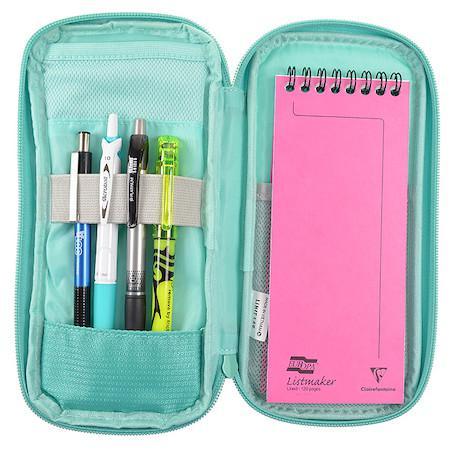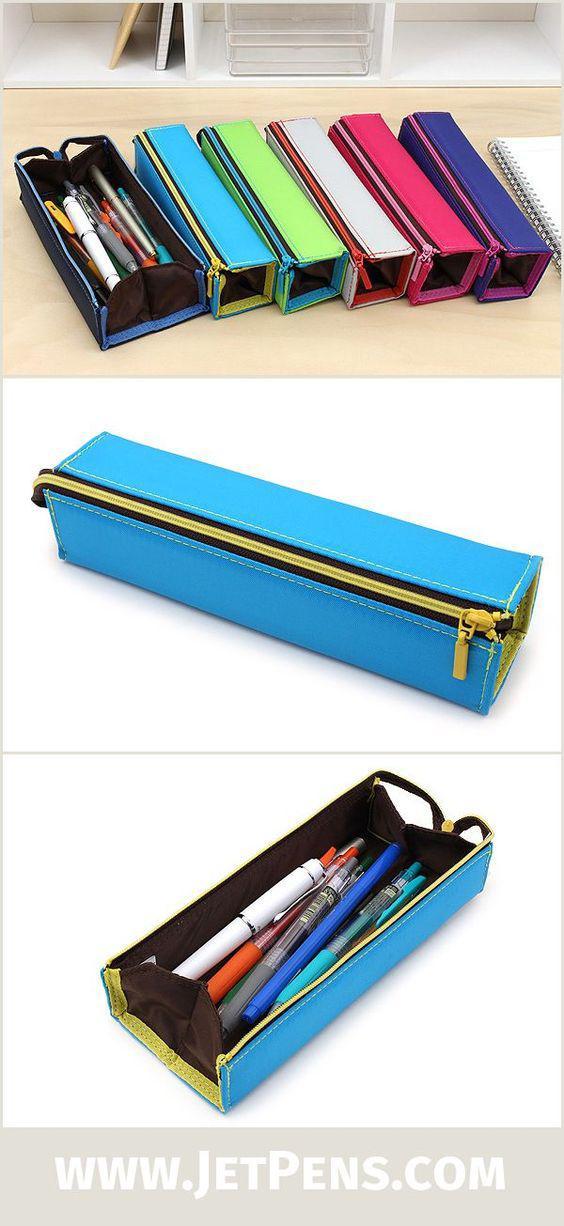The first image is the image on the left, the second image is the image on the right. Evaluate the accuracy of this statement regarding the images: "An image shows a hand opening a blue pencil case.". Is it true? Answer yes or no. No. 